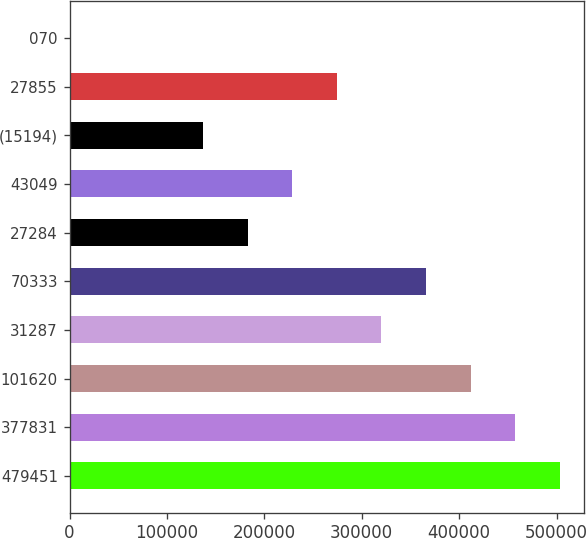Convert chart. <chart><loc_0><loc_0><loc_500><loc_500><bar_chart><fcel>479451<fcel>377831<fcel>101620<fcel>31287<fcel>70333<fcel>27284<fcel>43049<fcel>(15194)<fcel>27855<fcel>070<nl><fcel>503293<fcel>457539<fcel>411785<fcel>320277<fcel>366031<fcel>183016<fcel>228770<fcel>137262<fcel>274524<fcel>0.5<nl></chart> 